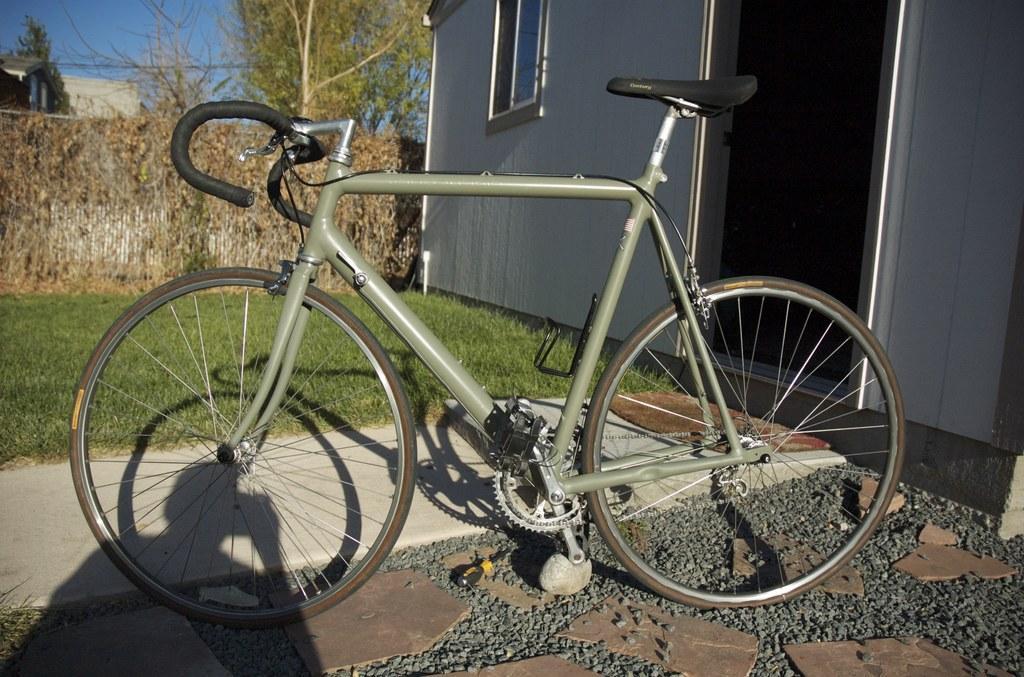Describe this image in one or two sentences. In the middle of this image, there is a gray color bicycle parked. In the background, there is a building having a glass window, there are trees, buildings, plants and grass on the ground and there are clouds in the blue sky. 